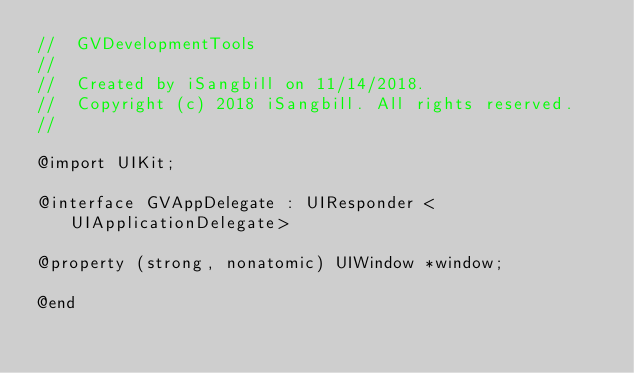Convert code to text. <code><loc_0><loc_0><loc_500><loc_500><_C_>//  GVDevelopmentTools
//
//  Created by iSangbill on 11/14/2018.
//  Copyright (c) 2018 iSangbill. All rights reserved.
//

@import UIKit;

@interface GVAppDelegate : UIResponder <UIApplicationDelegate>

@property (strong, nonatomic) UIWindow *window;

@end
</code> 